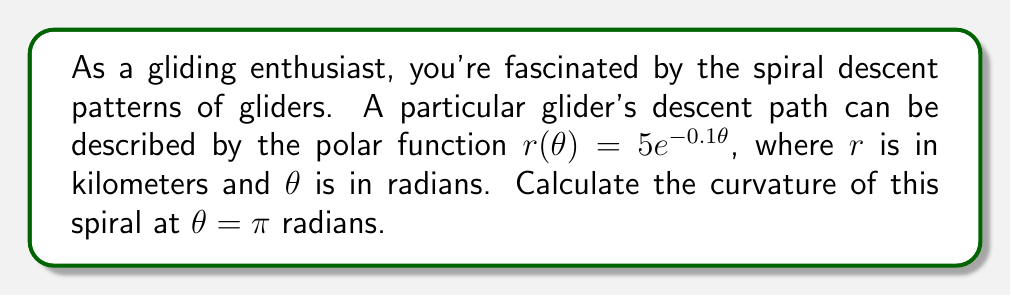What is the answer to this math problem? To find the curvature of a polar curve, we'll use the formula:

$$\kappa = \frac{|r^2 + 2(r')^2 - rr''|}{(r^2 + (r')^2)^{3/2}}$$

Where $r = r(\theta)$, $r' = \frac{dr}{d\theta}$, and $r'' = \frac{d^2r}{d\theta^2}$.

Step 1: Calculate $r$, $r'$, and $r''$
$r(\theta) = 5e^{-0.1\theta}$
$r'(\theta) = -0.5e^{-0.1\theta}$
$r''(\theta) = 0.05e^{-0.1\theta}$

Step 2: Evaluate at $\theta = \pi$
$r(\pi) = 5e^{-0.1\pi} \approx 3.5746$
$r'(\pi) = -0.5e^{-0.1\pi} \approx -0.3575$
$r''(\pi) = 0.05e^{-0.1\pi} \approx 0.0357$

Step 3: Substitute into the curvature formula
$$\kappa = \frac{|(3.5746)^2 + 2(-0.3575)^2 - (3.5746)(0.0357)|}{((3.5746)^2 + (-0.3575)^2)^{3/2}}$$

Step 4: Simplify and calculate
$$\kappa = \frac{|12.7778 + 0.2556 - 0.1276|}{(12.7778 + 0.1278)^{3/2}} \approx 0.2799$$

Therefore, the curvature of the glider's spiral descent at $\theta = \pi$ radians is approximately 0.2799 km^(-1).
Answer: $\kappa \approx 0.2799$ km^(-1) 